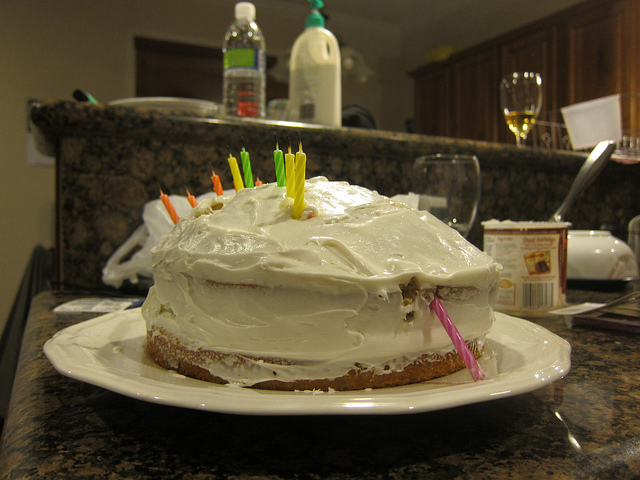Can you tell anything about the setting of this photo? The image shows a kitchen counter with the cake placed on it. In the background, there's a bottle and various kitchen items, suggesting the photo was taken in a home. The lighting indicates it's indoors and possibly taken during an evening event, as it gives off a warm ambience. 